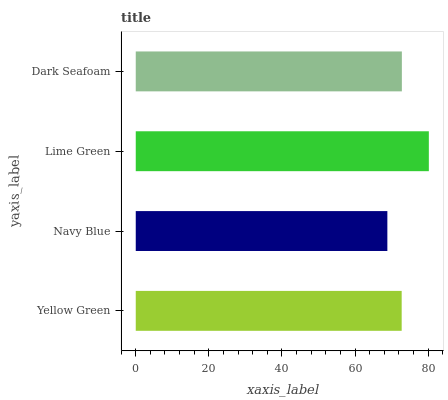Is Navy Blue the minimum?
Answer yes or no. Yes. Is Lime Green the maximum?
Answer yes or no. Yes. Is Lime Green the minimum?
Answer yes or no. No. Is Navy Blue the maximum?
Answer yes or no. No. Is Lime Green greater than Navy Blue?
Answer yes or no. Yes. Is Navy Blue less than Lime Green?
Answer yes or no. Yes. Is Navy Blue greater than Lime Green?
Answer yes or no. No. Is Lime Green less than Navy Blue?
Answer yes or no. No. Is Dark Seafoam the high median?
Answer yes or no. Yes. Is Yellow Green the low median?
Answer yes or no. Yes. Is Lime Green the high median?
Answer yes or no. No. Is Lime Green the low median?
Answer yes or no. No. 